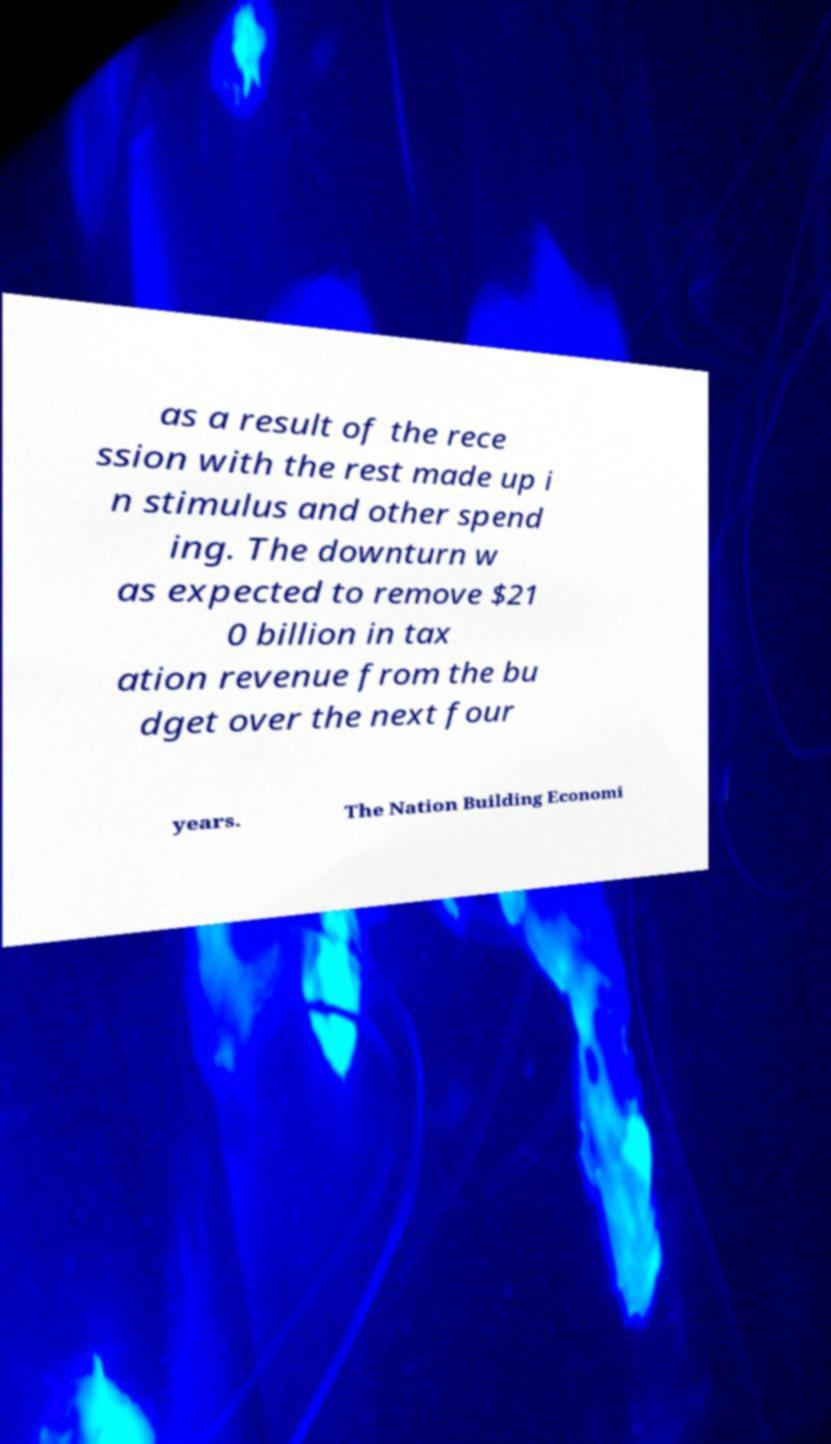Could you extract and type out the text from this image? as a result of the rece ssion with the rest made up i n stimulus and other spend ing. The downturn w as expected to remove $21 0 billion in tax ation revenue from the bu dget over the next four years. The Nation Building Economi 